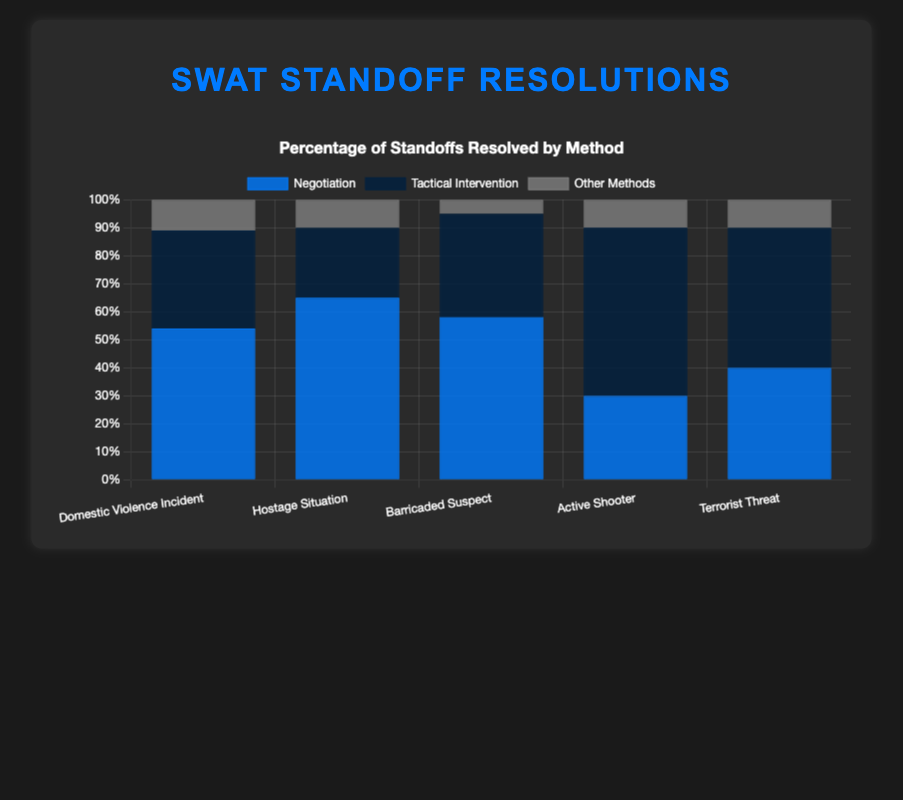Which type of standoff has the highest percentage resolved through negotiation? Check the height of blue bars for each type of standoff; the highest blue bar indicates the highest percentage of negotiation resolution. "Hostage Situation" has the highest at 65%.
Answer: Hostage Situation Which type of standoff is most likely resolved through tactical intervention? Check the height of dark blue bars for each type of standoff; the highest dark blue bar indicates the highest percentage of tactical intervention. "Active Shooter" has the highest at 60%.
Answer: Active Shooter What is the total percentage of standoffs resolved through other methods for Domestic Violence Incident and Terrorist Threat? Sum the percentages of "Other Methods" for both "Domestic Violence Incident" (11%) and "Terrorist Threat" (10%). 11% + 10% = 21%.
Answer: 21% How does the percentage of tactical interventions for Barricaded Suspect compare to those for Domestic Violence Incident? Compare the heights of the dark blue bars for "Barricaded Suspect" (37%) and "Domestic Violence Incident" (35%). 37% is greater than 35%.
Answer: Barricaded Suspect has a higher percentage Which type of standoff has the least percentage resolved through other methods? Check the shortest gray bar among all standoff types; the shortest indicates the least percentage of other methods. "Barricaded Suspect" has the least at 5%.
Answer: Barricaded Suspect What is the difference in percentage of negotiation resolutions between Hostage Situation and Active Shooter standoffs? Subtract the percentage of negotiation resolutions for "Active Shooter" (30%) from "Hostage Situation" (65%): 65% - 30% = 35%.
Answer: 35% Which type of standoff has nearly equal resolution percentages through negotiation and tactical intervention? Compare the heights of blue and dark blue bars within each standoff type. "Terrorist Threat" has negotiation at 40% and tactical intervention at 50%, which are close.
Answer: Terrorist Threat What is the average percentage of negotiation resolutions across all types of standoffs? Calculate the sum of negotiation percentages for all standoffs (54% + 65% + 58% + 30% + 40%) and then divide by the number of types (5): (54 + 65 + 58 + 30 + 40)/5 = 247/5 = 49.4%.
Answer: 49.4% What is the combined percentage of negotiation and tactical interventions for Domestic Violence Incident? Sum the percentages of "Negotiation" (54%) and "Tactical Intervention" (35%) for "Domestic Violence Incident": 54% + 35% = 89%.
Answer: 89% How do the resolution percentages through other methods compare between Hostage Situation and Active Shooter standoffs? Compare the heights of the gray bars for "Hostage Situation" (10%) and "Active Shooter" (10%). Both have the same percentage.
Answer: Equal 